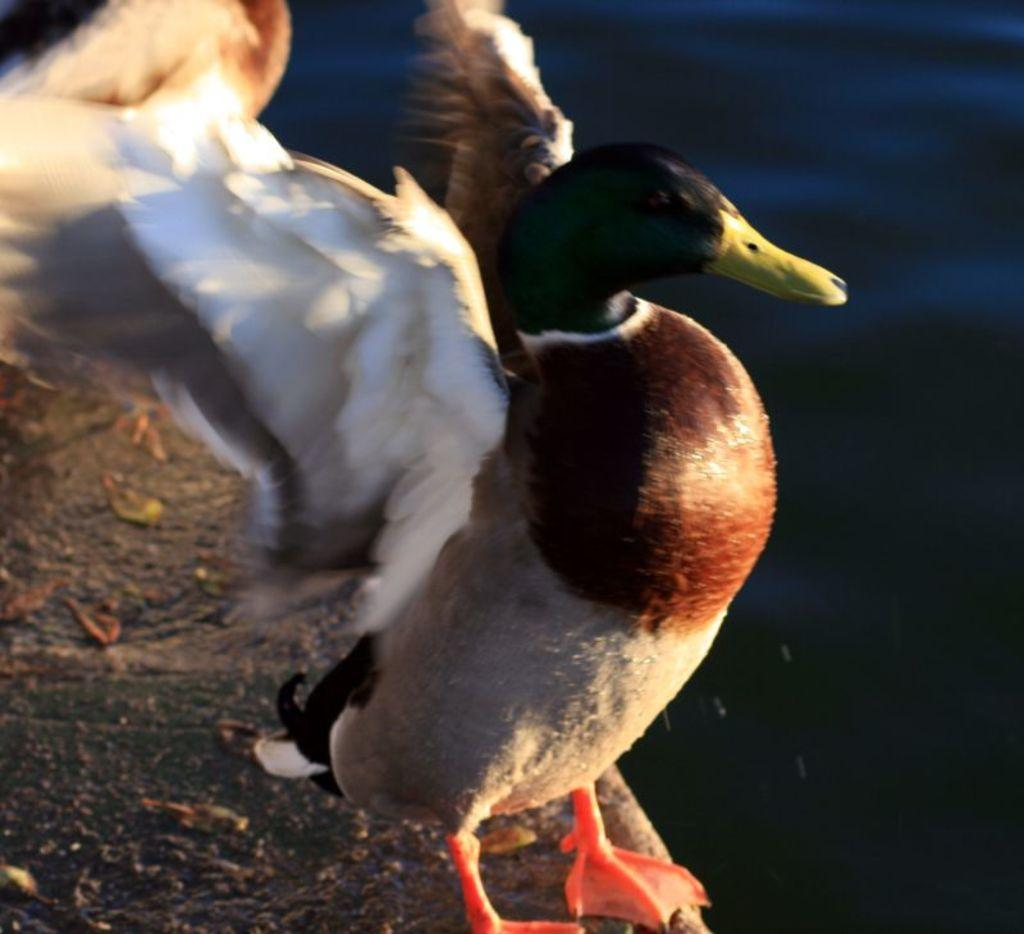What type of animal is in the image? There is a bird in the image. What colors can be seen on the bird? The bird is black and brown in color. What is located at the bottom of the image? There is a rock at the bottom of the image. How would you describe the background of the image? The background of the image is blurred. What subject is the bird teaching in the image? There is no indication in the image that the bird is teaching any subject. Can you see any bubbles around the bird in the image? There are no bubbles visible in the image. 